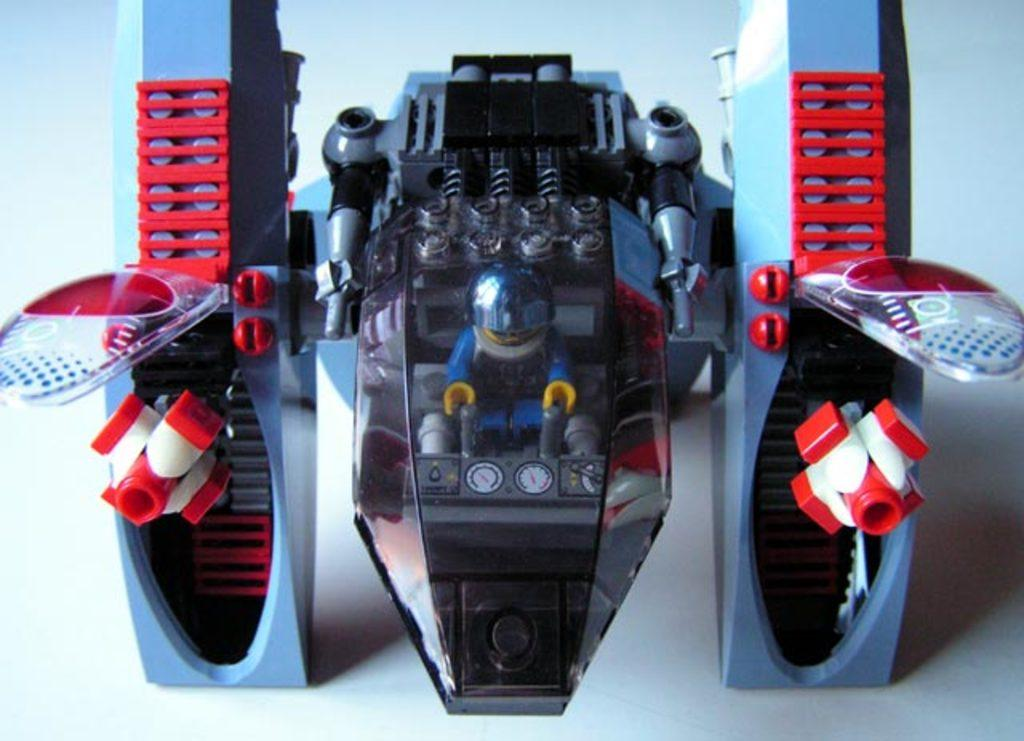What type of lego creation is in the image? There is a lego spaceship in the image. What is placed inside the lego spaceship? There is a lego toy sitting in the middle of the spaceship. Where are the lego spaceship and toy located? Both the lego spaceship and the lego toy are on a table. How does the fan help the lego spaceship in the image? There is no fan present in the image, so it cannot help the lego spaceship. 